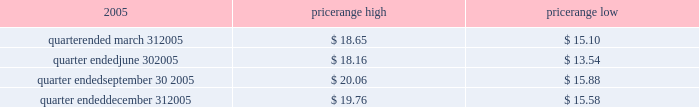Item 4 .
Submission of matters to a vote of security holders no matters were submitted to a vote of security holders during the fourth quarter of 2005 .
Part ii item 5 .
Market for the registrant 2019s common equity , related stockholder matters and issuer purchases of equity securities market information our series a common stock has traded on the new york stock exchange under the symbol 2018 2018ce 2019 2019 since january 21 , 2005 .
The closing sale price of our series a common stock , as reported by the new york stock exchange , on march 6 , 2006 was $ 20.98 .
The table sets forth the high and low intraday sales prices per share of our common stock , as reported by the new york stock exchange , for the periods indicated. .
Holders no shares of celanese 2019s series b common stock are issued and outstanding .
As of march 6 , 2006 , there were 51 holders of record of our series a common stock , and one holder of record of our perpetual preferred stock .
By including persons holding shares in broker accounts under street names , however , we estimate our shareholder base to be approximately 6800 as of march 6 , 2006 .
Dividend policy in july 2005 , our board of directors adopted a policy of declaring , subject to legally available funds , a quarterly cash dividend on each share of our common stock at an annual rate initially equal to approximately 1% ( 1 % ) of the $ 16 price per share in the initial public offering of our series a common stock ( or $ 0.16 per share ) unless our board of directors , in its sole discretion , determines otherwise , commencing the second quarter of 2005 .
Pursuant to this policy , the company paid the quarterly dividends of $ 0.04 per share on august 11 , 2005 , november 1 , 2005 and february 1 , 2006 .
Based on the number of outstanding shares of our series a common stock , the anticipated annual cash dividend is approximately $ 25 million .
However , there is no assurance that sufficient cash will be available in the future to pay such dividend .
Further , such dividends payable to holders of our series a common stock cannot be declared or paid nor can any funds be set aside for the payment thereof , unless we have paid or set aside funds for the payment of all accumulated and unpaid dividends with respect to the shares of our preferred stock , as described below .
Our board of directors may , at any time , modify or revoke our dividend policy on our series a common stock .
We are required under the terms of the preferred stock to pay scheduled quarterly dividends , subject to legally available funds .
For so long as the preferred stock remains outstanding , ( 1 ) we will not declare , pay or set apart funds for the payment of any dividend or other distribution with respect to any junior stock or parity stock and ( 2 ) neither we , nor any of our subsidiaries , will , subject to certain exceptions , redeem , purchase or otherwise acquire for consideration junior stock or parity stock through a sinking fund or otherwise , in each case unless we have paid or set apart funds for the payment of all accumulated and unpaid dividends with respect to the shares of preferred stock and any parity stock for all preceding dividend periods .
Pursuant to this policy , the company paid the quarterly dividends of $ 0.265625 on its 4.25% ( 4.25 % ) convertible perpetual preferred stock on august 1 , 2005 , november 1 , 2005 and february 1 , 2006 .
The anticipated annual cash dividend is approximately $ 10 million. .
What is the maximum variance during the quarter ended in september 31 , 2005? 
Computations: (20.06 - 15.88)
Answer: 4.18. 